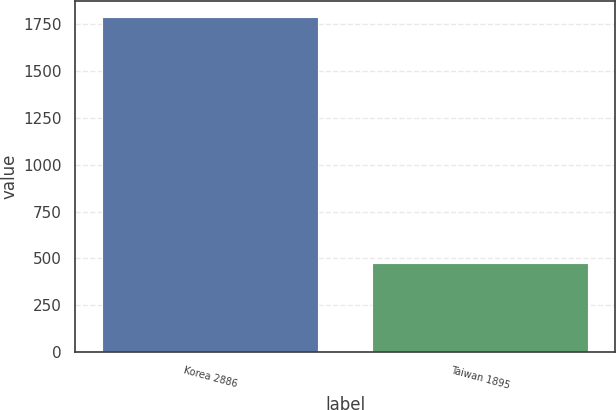Convert chart. <chart><loc_0><loc_0><loc_500><loc_500><bar_chart><fcel>Korea 2886<fcel>Taiwan 1895<nl><fcel>1785<fcel>473<nl></chart> 